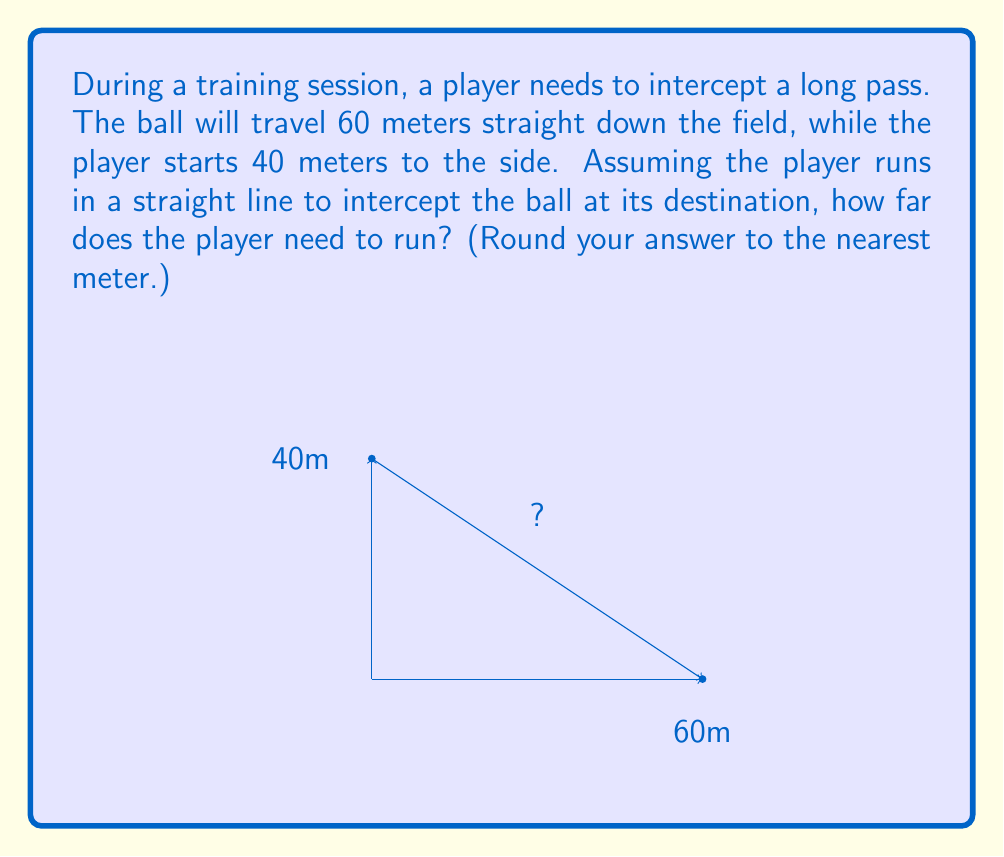Can you answer this question? Let's approach this step-by-step using the Pythagorean theorem:

1) The situation forms a right triangle, where:
   - The base is the path of the ball (60 meters)
   - The height is the initial distance of the player from the ball's path (40 meters)
   - The hypotenuse is the distance the player needs to run

2) Let's call the distance the player needs to run $x$.

3) According to the Pythagorean theorem:
   $x^2 = 60^2 + 40^2$

4) Let's calculate:
   $x^2 = 3600 + 1600 = 5200$

5) To find $x$, we need to take the square root of both sides:
   $x = \sqrt{5200}$

6) Using a calculator:
   $x \approx 72.11$ meters

7) Rounding to the nearest meter:
   $x \approx 72$ meters

Therefore, the player needs to run approximately 72 meters to intercept the ball.
Answer: 72 meters 